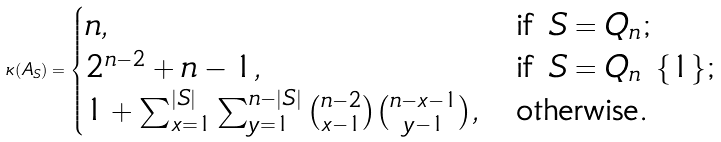<formula> <loc_0><loc_0><loc_500><loc_500>\kappa ( A _ { S } ) = \begin{cases} n , & \text {if $S=Q_{n}$;} \\ 2 ^ { n - 2 } + n - 1 , & \text {if $S=Q_{n}\ \{1\} $;} \\ 1 + \sum _ { x = 1 } ^ { | S | } \sum _ { y = 1 } ^ { n - | S | } \binom { n - 2 } { x - 1 } \binom { n - x - 1 } { y - 1 } , & \text {otherwise.} \end{cases}</formula> 